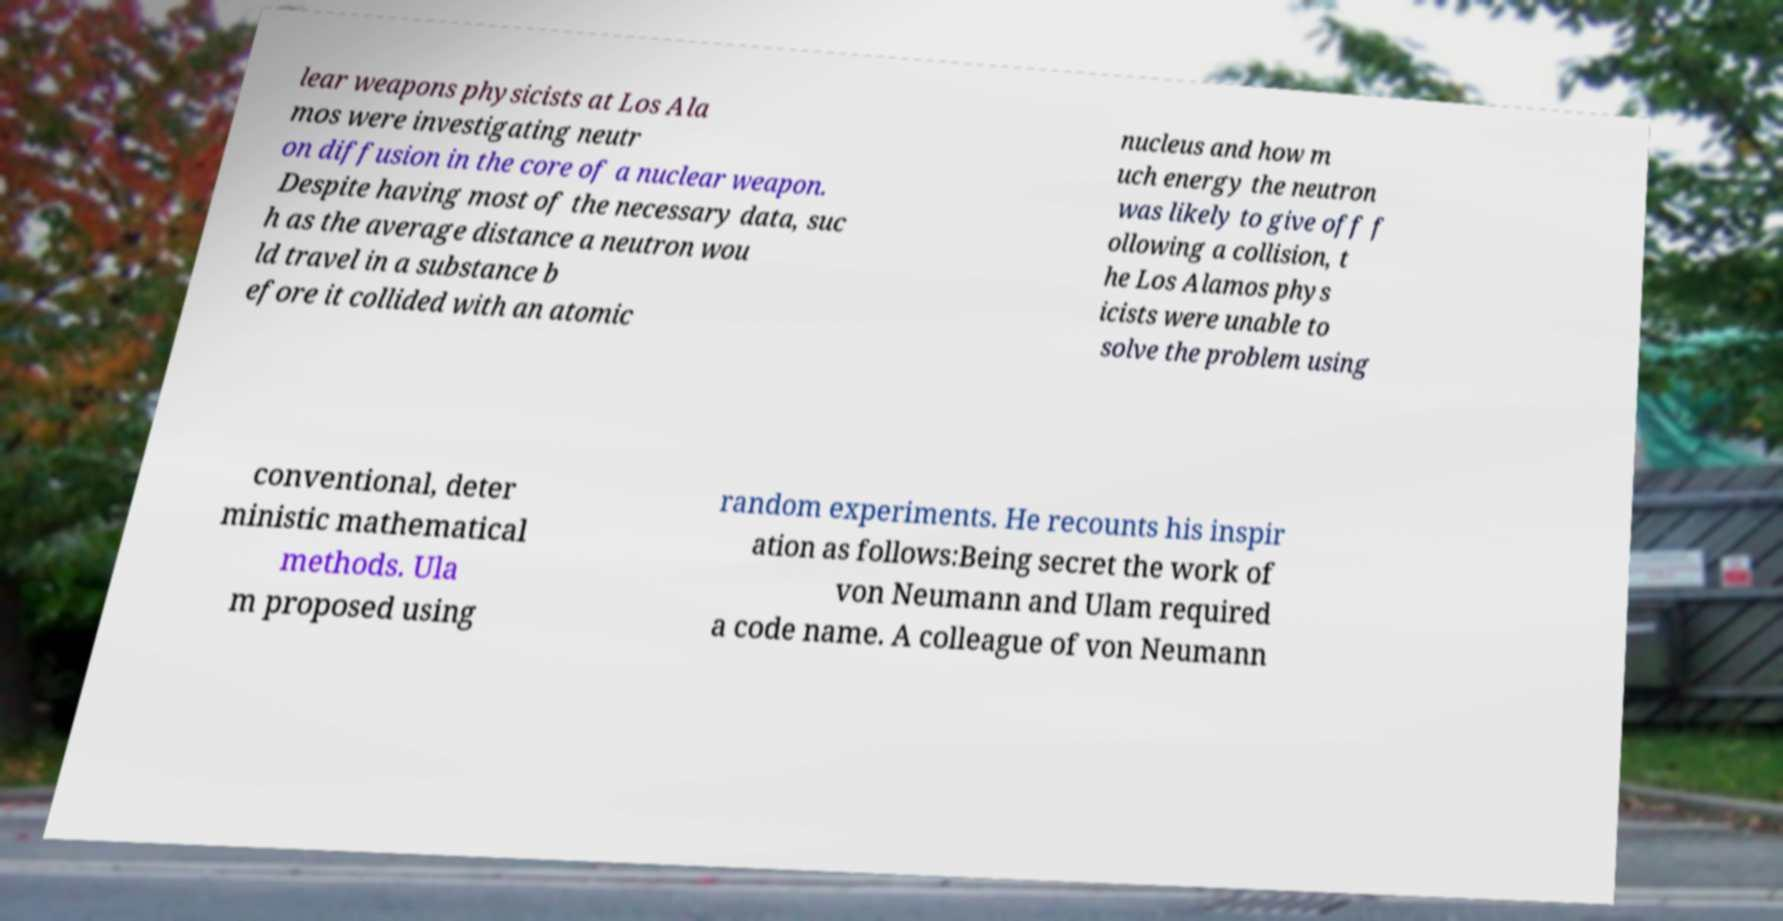Please identify and transcribe the text found in this image. lear weapons physicists at Los Ala mos were investigating neutr on diffusion in the core of a nuclear weapon. Despite having most of the necessary data, suc h as the average distance a neutron wou ld travel in a substance b efore it collided with an atomic nucleus and how m uch energy the neutron was likely to give off f ollowing a collision, t he Los Alamos phys icists were unable to solve the problem using conventional, deter ministic mathematical methods. Ula m proposed using random experiments. He recounts his inspir ation as follows:Being secret the work of von Neumann and Ulam required a code name. A colleague of von Neumann 